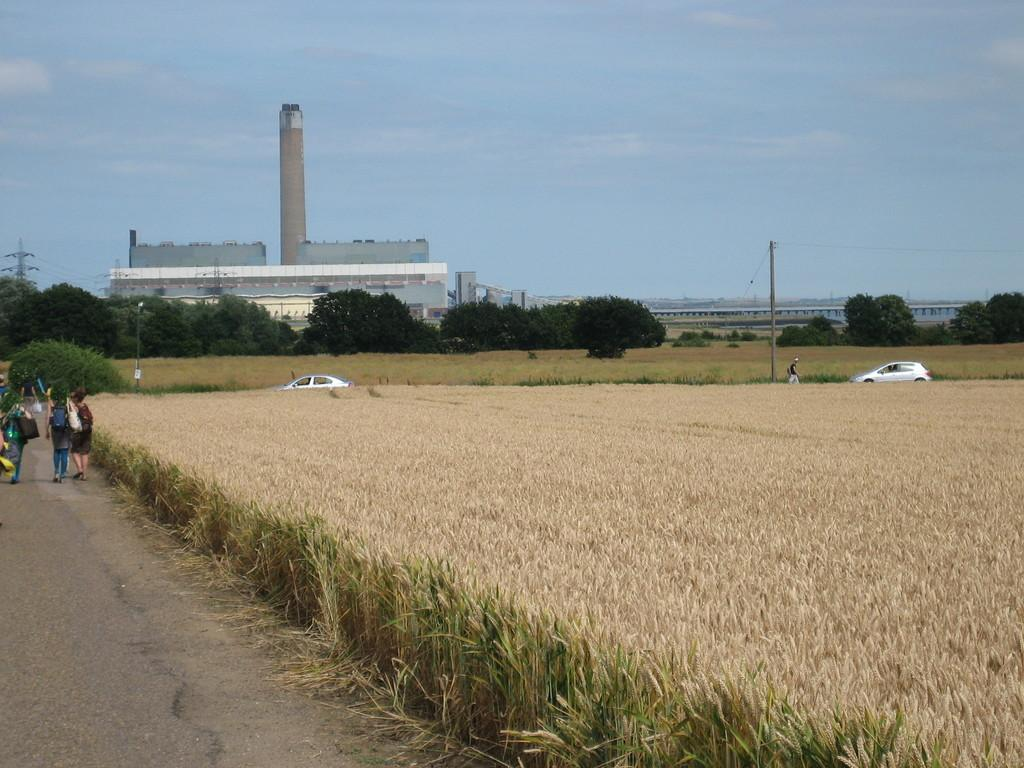What can be seen in the background of the image? In the background of the image, there is a sky, a building, and a tower. What structures are present in the image? There are poles and transmission wires in the image. What type of natural environment is visible in the image? There are trees, fields, and a road in the image. What is moving in the image? Vehicles are visible in the image. What else can be seen in the image? There are objects and people present in the image. What type of vegetable is being harvested in the fields in the image? There are no vegetables or harvesting activities visible in the fields in the image. How does the muscle of the person in the image help them perform their tasks? There are no visible muscles or tasks being performed by people in the image. 